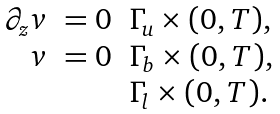Convert formula to latex. <formula><loc_0><loc_0><loc_500><loc_500>\begin{array} { r l l } \partial _ { z } v & = 0 & \Gamma _ { u } \times ( 0 , T ) , \\ v & = 0 & \Gamma _ { b } \times ( 0 , T ) , \\ & & \Gamma _ { l } \times ( 0 , T ) . \\ \end{array}</formula> 